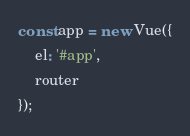Convert code to text. <code><loc_0><loc_0><loc_500><loc_500><_JavaScript_>
const app = new Vue({
    el: '#app',
    router
});
</code> 